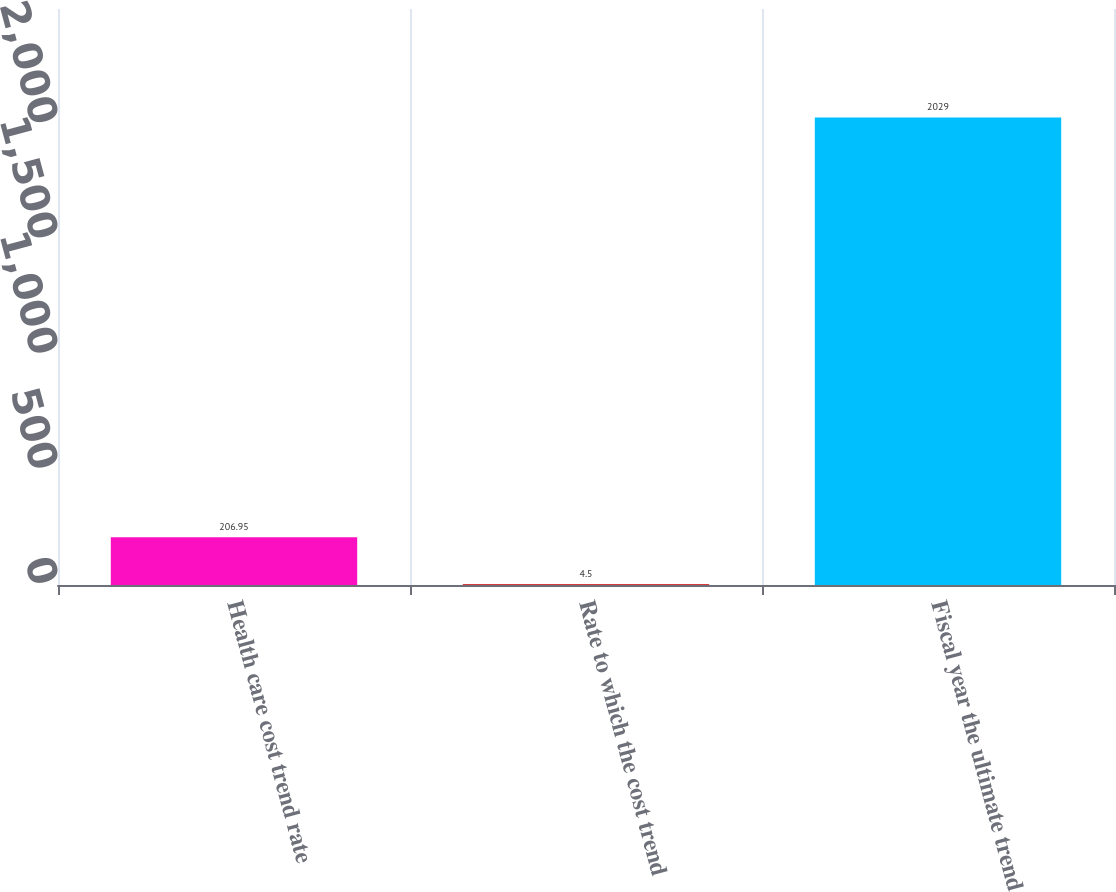Convert chart to OTSL. <chart><loc_0><loc_0><loc_500><loc_500><bar_chart><fcel>Health care cost trend rate<fcel>Rate to which the cost trend<fcel>Fiscal year the ultimate trend<nl><fcel>206.95<fcel>4.5<fcel>2029<nl></chart> 